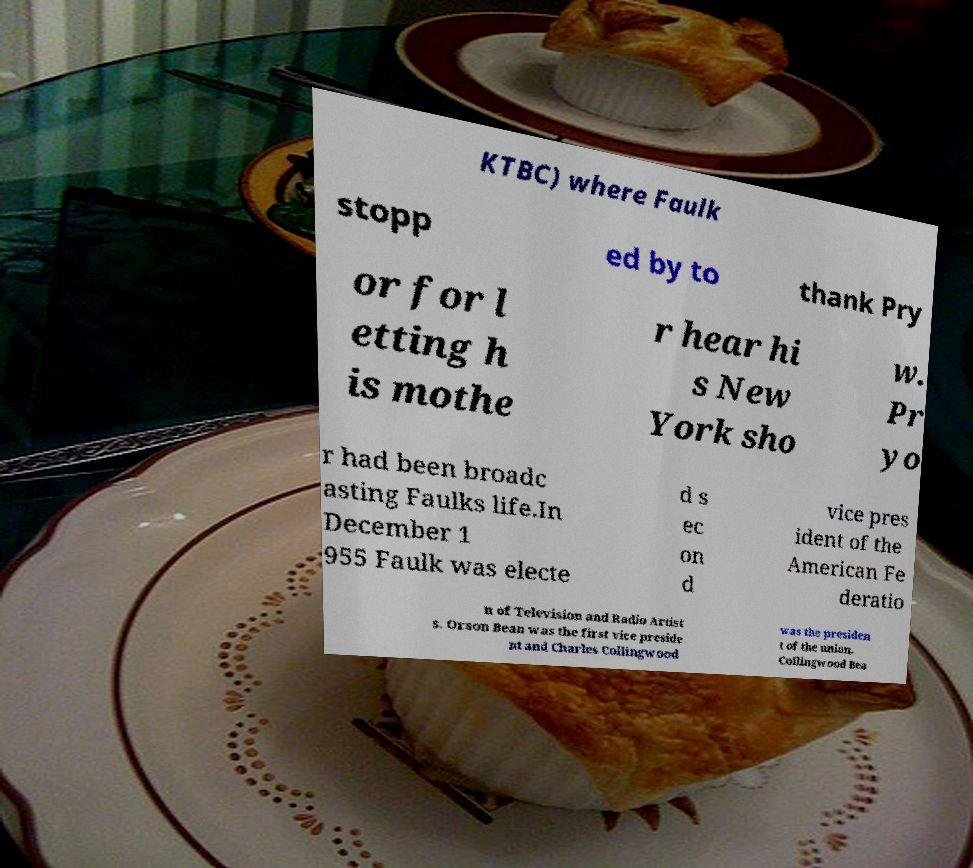Could you extract and type out the text from this image? KTBC) where Faulk stopp ed by to thank Pry or for l etting h is mothe r hear hi s New York sho w. Pr yo r had been broadc asting Faulks life.In December 1 955 Faulk was electe d s ec on d vice pres ident of the American Fe deratio n of Television and Radio Artist s. Orson Bean was the first vice preside nt and Charles Collingwood was the presiden t of the union. Collingwood Bea 